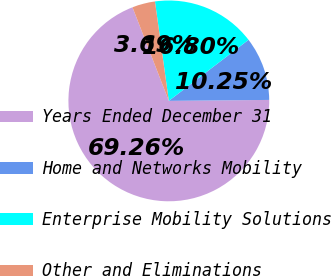Convert chart to OTSL. <chart><loc_0><loc_0><loc_500><loc_500><pie_chart><fcel>Years Ended December 31<fcel>Home and Networks Mobility<fcel>Enterprise Mobility Solutions<fcel>Other and Eliminations<nl><fcel>69.26%<fcel>10.25%<fcel>16.8%<fcel>3.69%<nl></chart> 